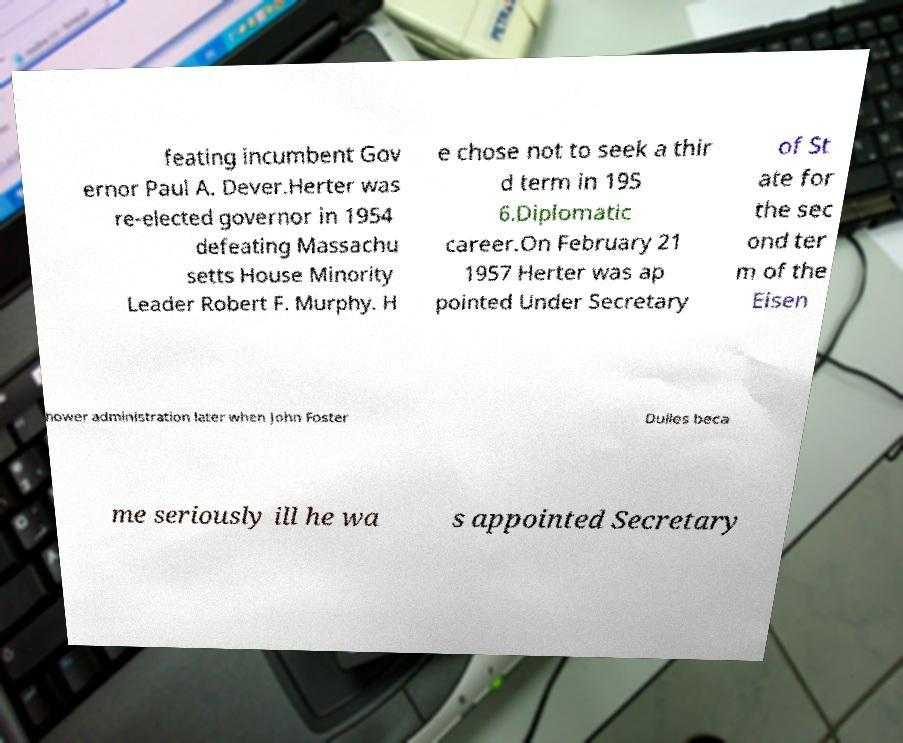Can you accurately transcribe the text from the provided image for me? feating incumbent Gov ernor Paul A. Dever.Herter was re-elected governor in 1954 defeating Massachu setts House Minority Leader Robert F. Murphy. H e chose not to seek a thir d term in 195 6.Diplomatic career.On February 21 1957 Herter was ap pointed Under Secretary of St ate for the sec ond ter m of the Eisen hower administration later when John Foster Dulles beca me seriously ill he wa s appointed Secretary 